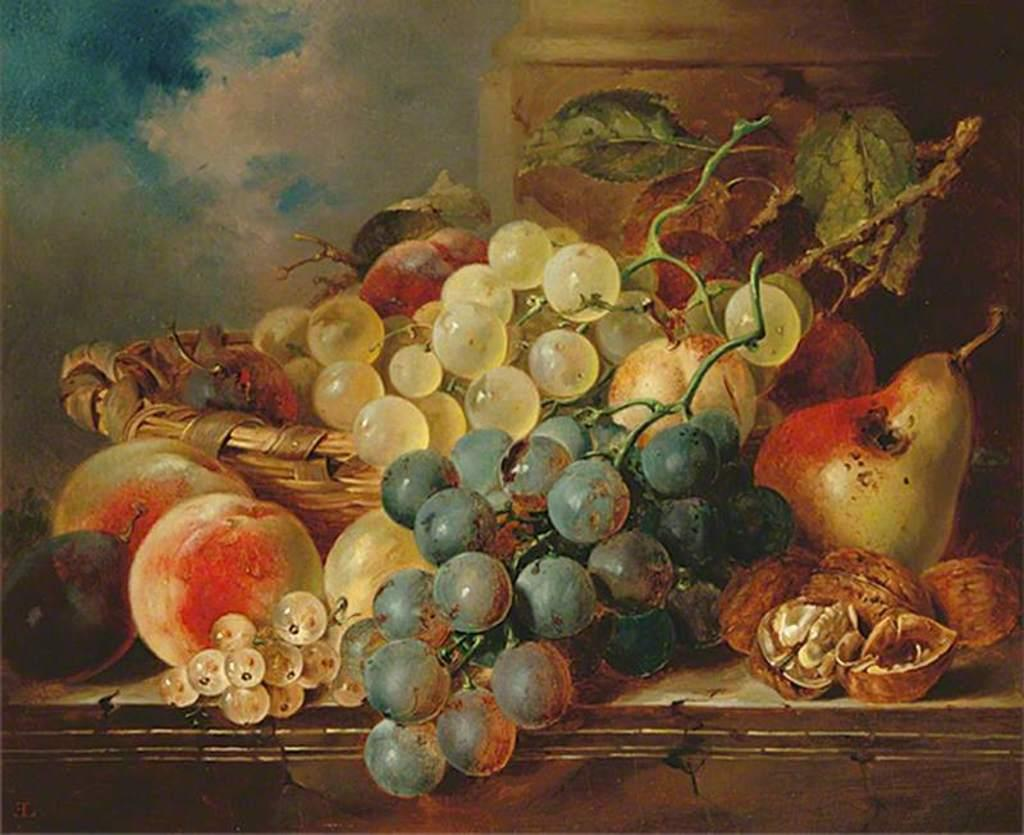What type of artwork is depicted in the image? The image is a painting. What object can be seen in the painting? There is a basket in the painting. What items are inside the basket? There are fruits in the painting. What additional elements are present in the painting? There are leaves in the painting. What can be seen in the background of the painting? The sky is visible in the background of the painting. What specific feature of the sky can be observed? Clouds are present in the sky in the background of the painting. Is there a net visible in the painting? No, there is no net present in the painting. Does the existence of the painting prove the existence of the artist? The existence of the painting does not necessarily prove the existence of the artist, as the artist could be unknown or deceased. 